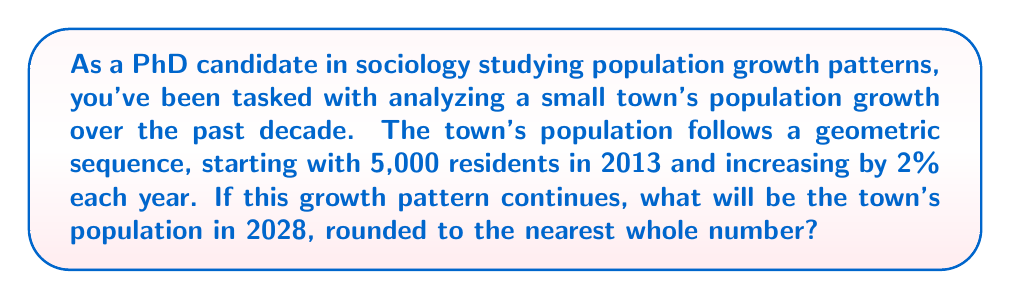Teach me how to tackle this problem. Let's approach this step-by-step:

1) We're dealing with a geometric sequence where:
   - Initial population (in 2013): $a = 5000$
   - Common ratio: $r = 1 + 2\% = 1.02$
   - Number of years from 2013 to 2028: $n = 15$

2) The formula for the nth term of a geometric sequence is:
   $a_n = a \cdot r^{n-1}$

3) Plugging in our values:
   $a_{15} = 5000 \cdot (1.02)^{15-1}$
   $a_{15} = 5000 \cdot (1.02)^{14}$

4) Calculate $(1.02)^{14}$:
   $(1.02)^{14} \approx 1.3181709$

5) Multiply by the initial population:
   $5000 \cdot 1.3181709 \approx 6590.8545$

6) Round to the nearest whole number:
   $6590.8545 \approx 6591$

Therefore, if the growth pattern continues, the town's population in 2028 will be approximately 6,591 residents.
Answer: 6,591 